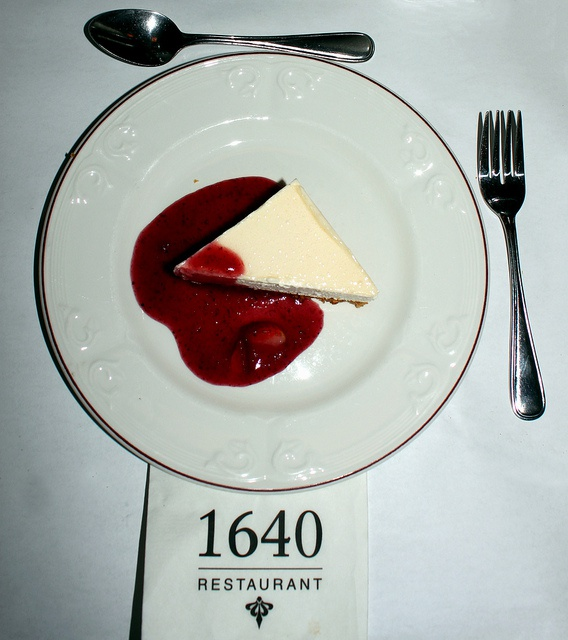Describe the objects in this image and their specific colors. I can see cake in gray, beige, and maroon tones, fork in gray, black, white, and blue tones, and spoon in gray, black, white, and darkgray tones in this image. 